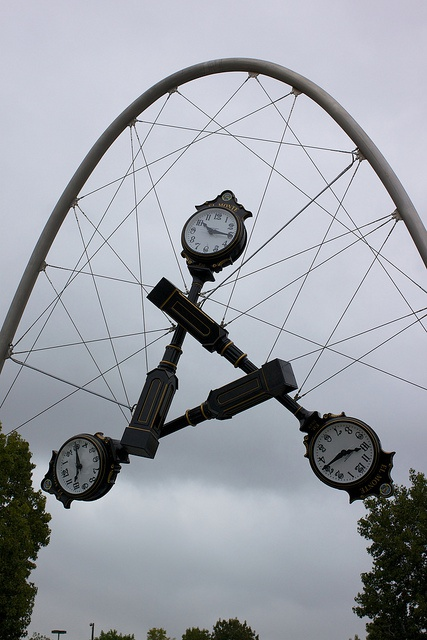Describe the objects in this image and their specific colors. I can see clock in lightgray, gray, black, and purple tones, clock in lightgray, darkgray, gray, and black tones, and clock in lightgray, gray, black, and purple tones in this image. 